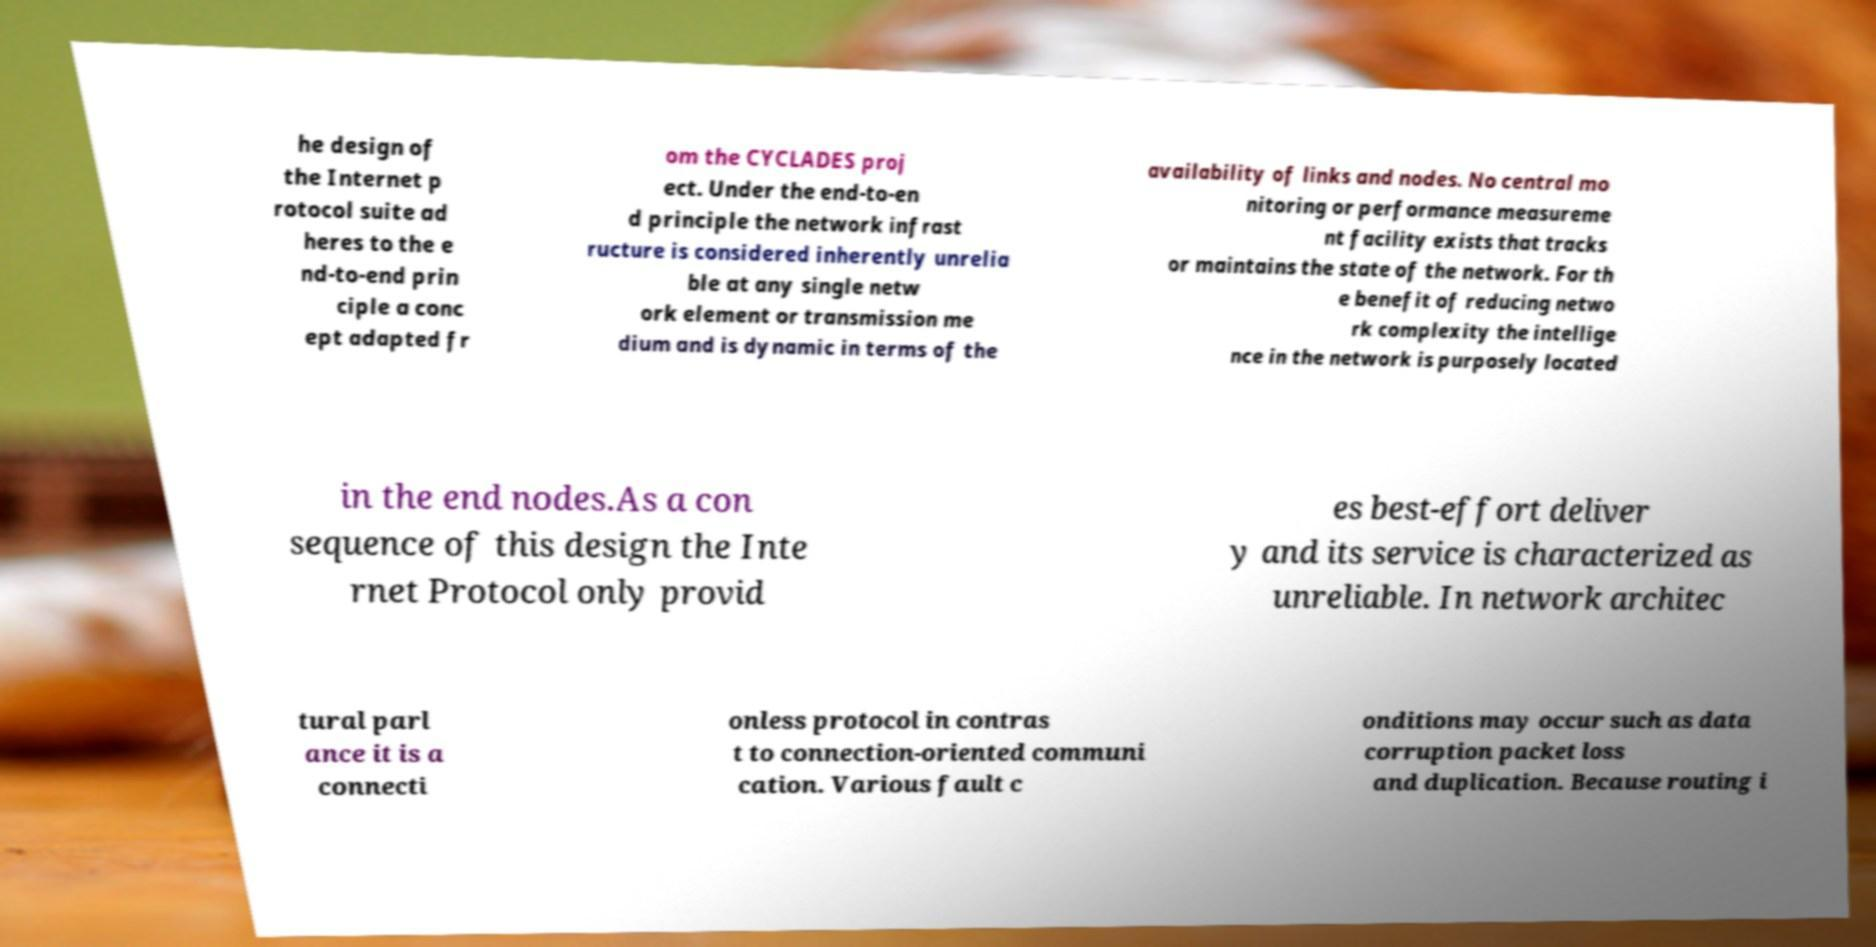Could you extract and type out the text from this image? he design of the Internet p rotocol suite ad heres to the e nd-to-end prin ciple a conc ept adapted fr om the CYCLADES proj ect. Under the end-to-en d principle the network infrast ructure is considered inherently unrelia ble at any single netw ork element or transmission me dium and is dynamic in terms of the availability of links and nodes. No central mo nitoring or performance measureme nt facility exists that tracks or maintains the state of the network. For th e benefit of reducing netwo rk complexity the intellige nce in the network is purposely located in the end nodes.As a con sequence of this design the Inte rnet Protocol only provid es best-effort deliver y and its service is characterized as unreliable. In network architec tural parl ance it is a connecti onless protocol in contras t to connection-oriented communi cation. Various fault c onditions may occur such as data corruption packet loss and duplication. Because routing i 